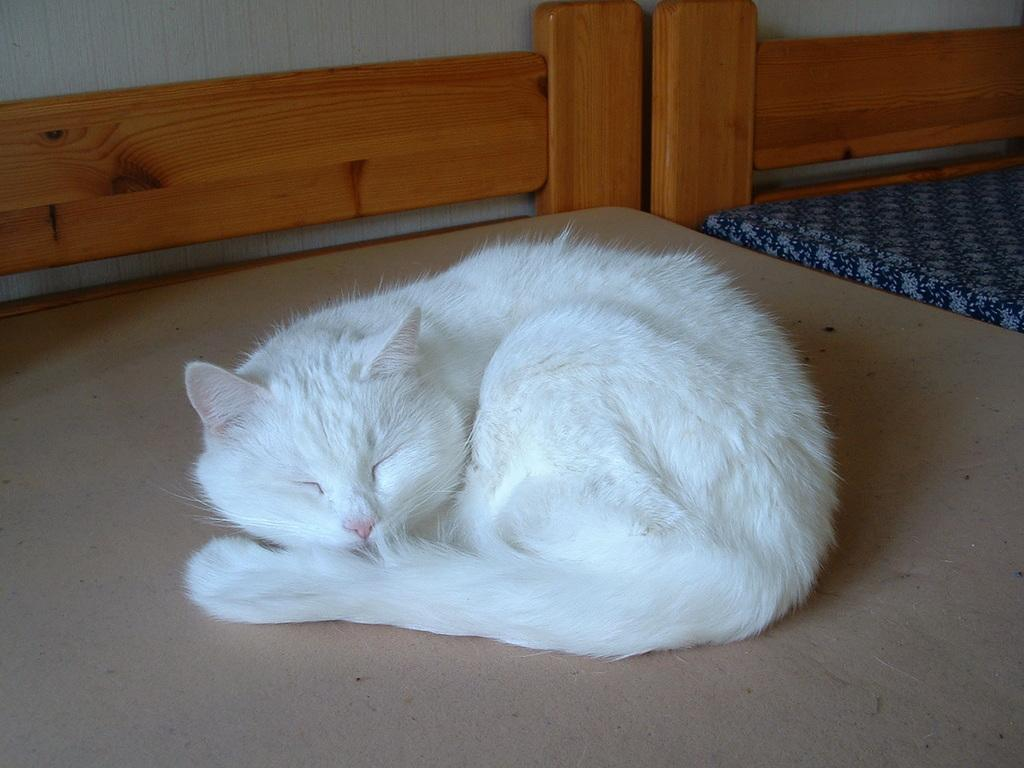What type of animal is in the image? There is a white cat in the image. Where is the cat located? The cat is laying on a wooden bench. What other furniture can be seen in the image? There is a bed in the image. What is visible in the background of the image? There is a wall visible in the image. How many frogs can be seen sitting on the twig in the image? There are no frogs or twigs present in the image. 